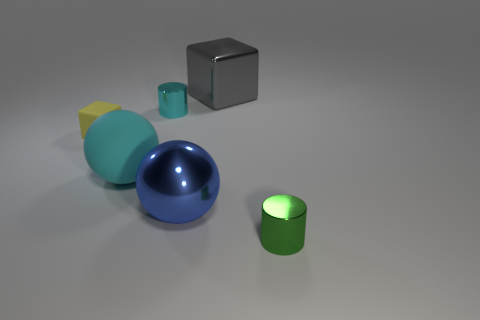Add 1 metallic things. How many objects exist? 7 Subtract all cylinders. How many objects are left? 4 Subtract 1 cyan cylinders. How many objects are left? 5 Subtract all blue balls. Subtract all yellow blocks. How many objects are left? 4 Add 2 small cyan metal cylinders. How many small cyan metal cylinders are left? 3 Add 1 cyan shiny spheres. How many cyan shiny spheres exist? 1 